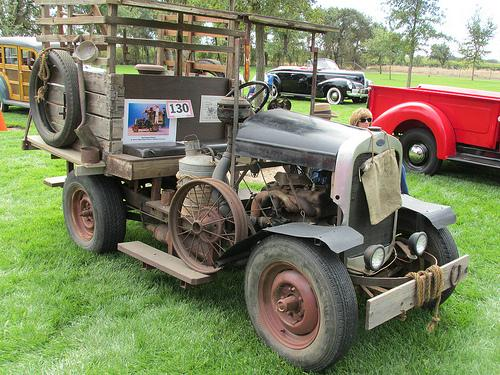Discuss the image's sentiment or general feeling in a sentence or two. The image conveys a nostalgic and interesting sentiment with a focus on old and worn-out vehicles, providing a glimpse into the past. In the scene, how many wheels of vehicles are present, and what is their condition? There are eight wheels of vehicles visible in the image, some of them look rusty, and one has a large black tire with a rusted rim. Describe any unusual or interesting objects found on these old vehicles. A rope wrapped around wood, a burlap sack hanging from a car, and a metal shovel on a truck are among the unusual and interesting objects found on these old vehicles. Which tasks can be performed with the information given about the headlight positions? Object detection and headlight position analysis can be performed using headlight-related information. Explain the objects that interact or relate to each other in the image. Some objects that relate to each other in the image are the wheels, bumpers, and headlights of the vehicles, as well as the woman with blonde hair standing next to a car. What is the main focus of the image and what is happening around it? The main focus of the image is old vehicles parked on grass and various parts of these vehicles, such as wheels, bumpers, and lights, are being highlighted. What type of vintage parts can you find in the image? Old steel automobile, wooden bumper, rusty metal wheel rim, and burlap sack hanging from a car are some vintage parts found in the image. Can you give a brief description of the people present in the image? There is a woman with blonde hair wearing sunglasses next to a car in the image. Mention three different tasks that can be performed using the information provided in this image. Object detection of vehicle parts, vehicle color recognition, and identification of people and their features in the image. List three different car colors mentioned in the image. The car is black, green brown and yellow, and the truck is red. 